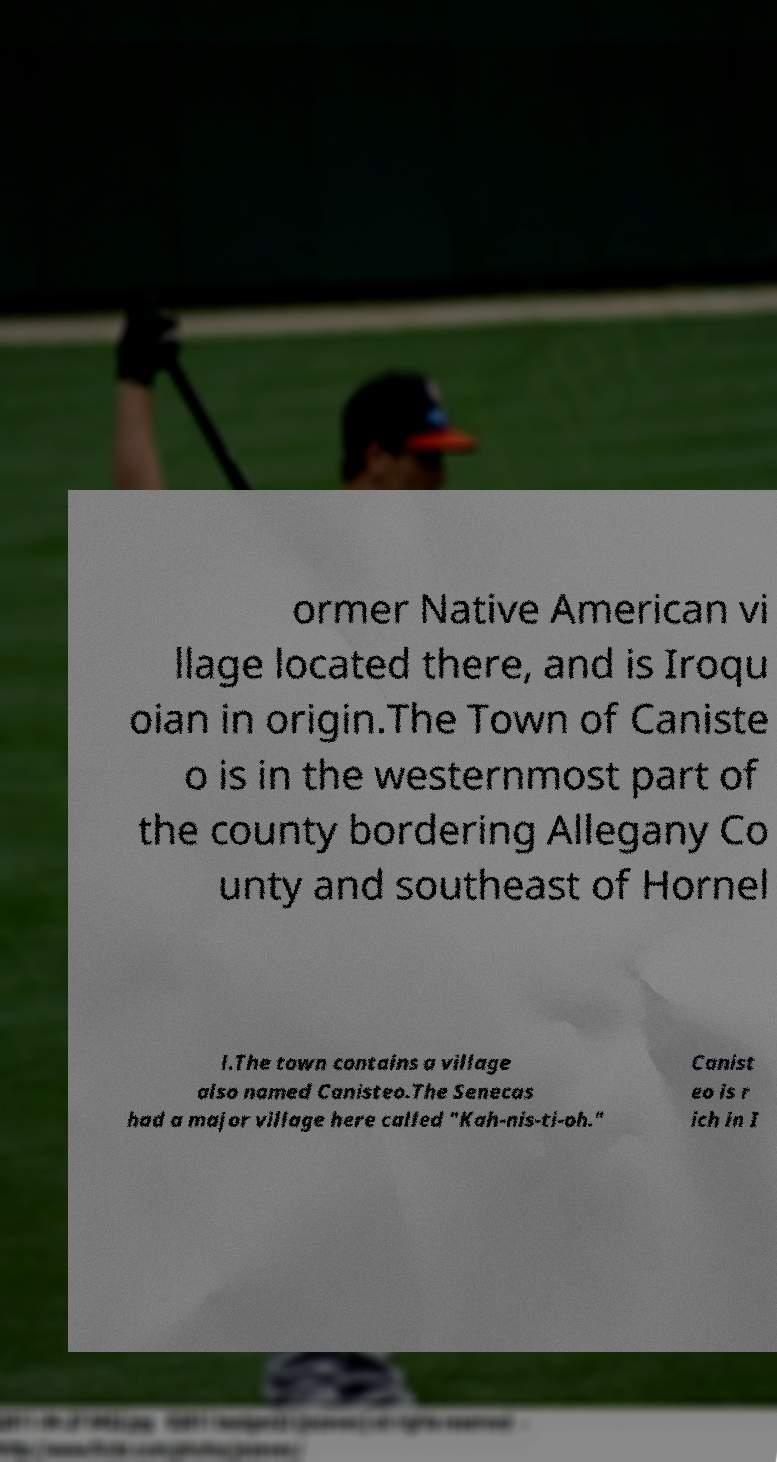Please identify and transcribe the text found in this image. ormer Native American vi llage located there, and is Iroqu oian in origin.The Town of Caniste o is in the westernmost part of the county bordering Allegany Co unty and southeast of Hornel l.The town contains a village also named Canisteo.The Senecas had a major village here called "Kah-nis-ti-oh." Canist eo is r ich in I 